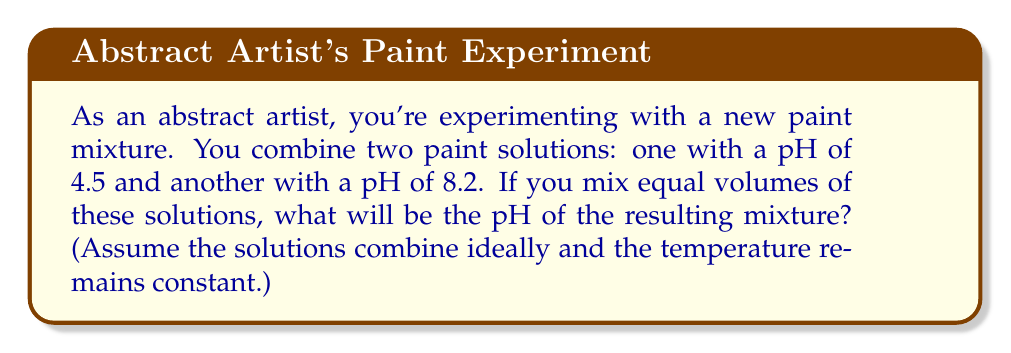Can you solve this math problem? Let's approach this step-by-step:

1) First, recall that pH is a logarithmic scale. The pH is defined as the negative logarithm (base 10) of the hydrogen ion concentration [H+]:

   $$ pH = -\log_{10}[H^+] $$

2) To find the pH of the mixture, we need to calculate the average hydrogen ion concentration, then convert back to pH.

3) For the first solution with pH 4.5:
   $$ [H^+]_1 = 10^{-4.5} = 3.16 \times 10^{-5} M $$

4) For the second solution with pH 8.2:
   $$ [H^+]_2 = 10^{-8.2} = 6.31 \times 10^{-9} M $$

5) Since we're mixing equal volumes, the average [H+] will be:
   $$ [H^+]_{avg} = \frac{[H^+]_1 + [H^+]_2}{2} = \frac{3.16 \times 10^{-5} + 6.31 \times 10^{-9}}{2} = 1.58 \times 10^{-5} M $$

6) Now, to get the pH of the mixture, we take the negative log of this average:
   $$ pH_{mixture} = -\log_{10}(1.58 \times 10^{-5}) = 4.80 $$

Therefore, the pH of the resulting mixture will be approximately 4.80.
Answer: 4.80 